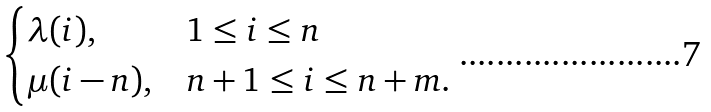Convert formula to latex. <formula><loc_0><loc_0><loc_500><loc_500>\begin{cases} \lambda ( i ) , & 1 \leq i \leq n \\ \mu ( i - n ) , & n + 1 \leq i \leq n + m . \end{cases}</formula> 